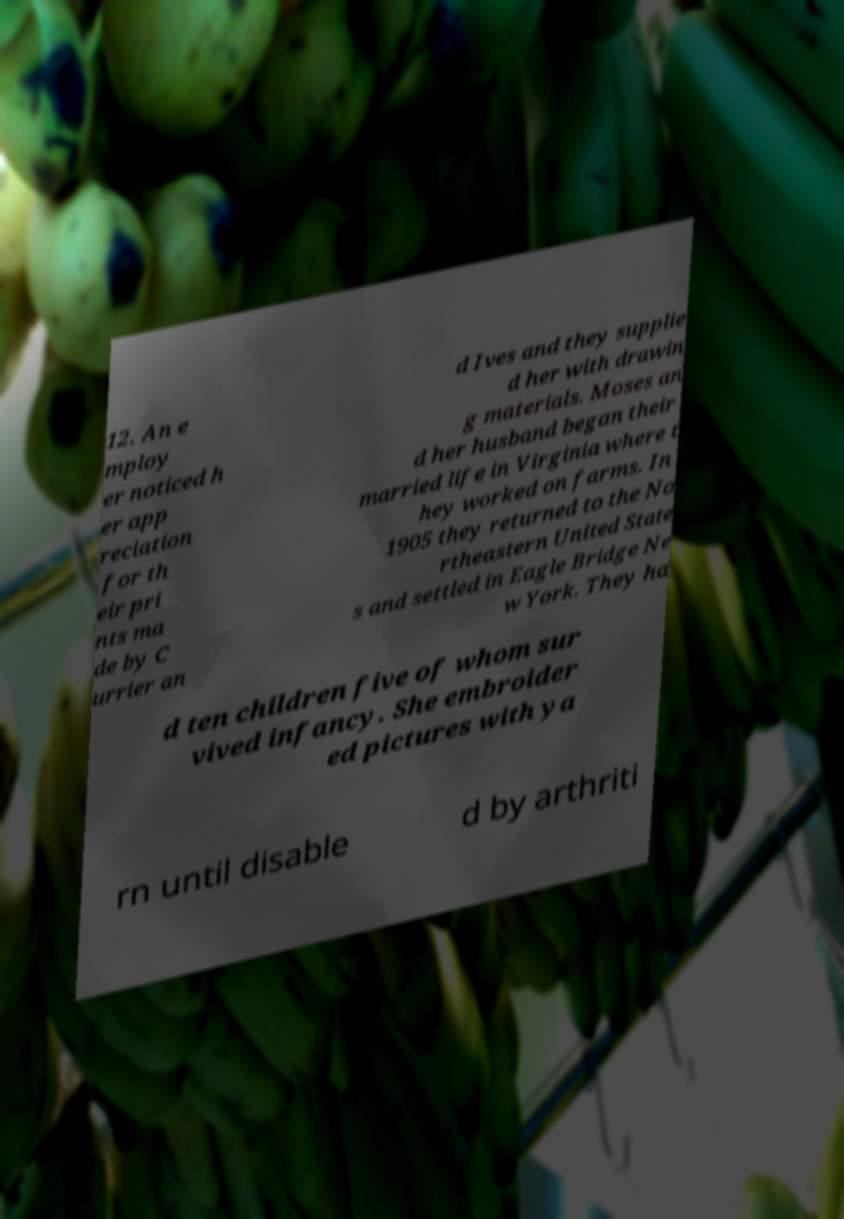Could you extract and type out the text from this image? 12. An e mploy er noticed h er app reciation for th eir pri nts ma de by C urrier an d Ives and they supplie d her with drawin g materials. Moses an d her husband began their married life in Virginia where t hey worked on farms. In 1905 they returned to the No rtheastern United State s and settled in Eagle Bridge Ne w York. They ha d ten children five of whom sur vived infancy. She embroider ed pictures with ya rn until disable d by arthriti 